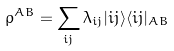Convert formula to latex. <formula><loc_0><loc_0><loc_500><loc_500>\rho ^ { A B } = \sum _ { i j } \lambda _ { i j } | i j \rangle \langle i j | _ { A B }</formula> 